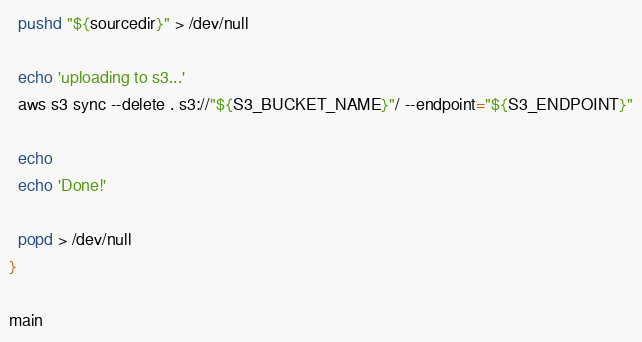<code> <loc_0><loc_0><loc_500><loc_500><_Bash_>  pushd "${sourcedir}" > /dev/null

  echo 'uploading to s3...'
  aws s3 sync --delete . s3://"${S3_BUCKET_NAME}"/ --endpoint="${S3_ENDPOINT}"

  echo
  echo 'Done!'

  popd > /dev/null
}

main
</code> 